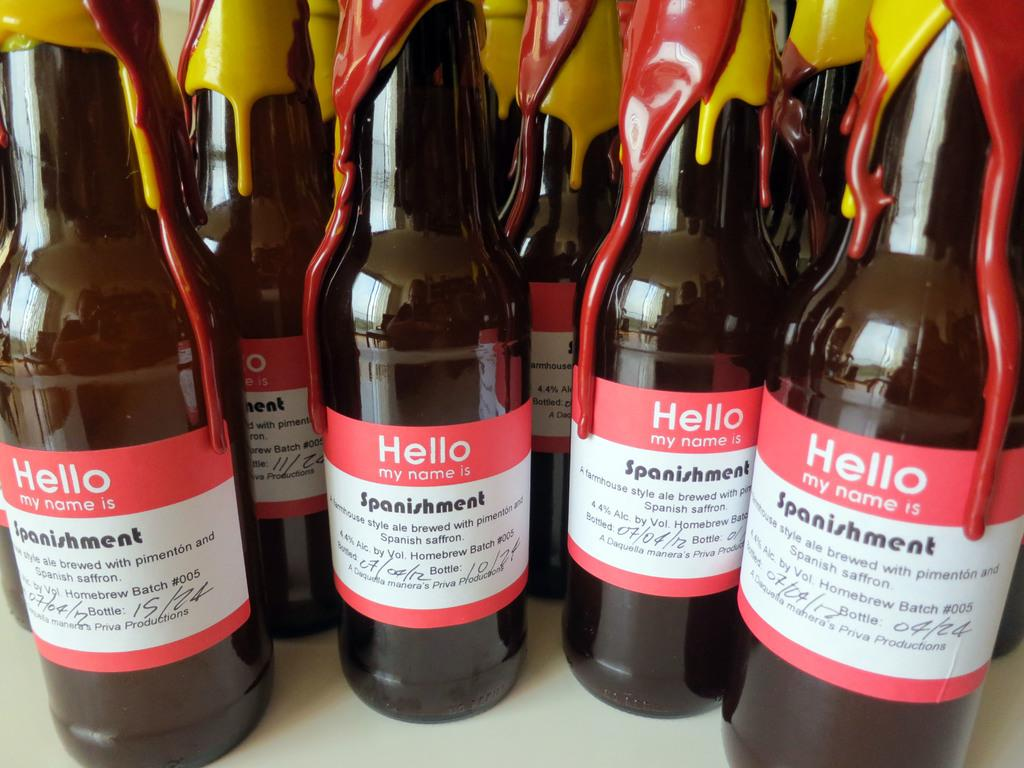<image>
Create a compact narrative representing the image presented. Bottles of beer have labels that look like name tags, Hello my name is. 